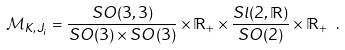<formula> <loc_0><loc_0><loc_500><loc_500>\mathcal { M } _ { K , J _ { i } } = \frac { S O ( 3 , 3 ) } { S O ( 3 ) \times S O ( 3 ) } \times \mathbb { R } _ { + } \times \frac { S l ( 2 , \mathbb { R } ) } { S O ( 2 ) } \times \mathbb { R } _ { + } \ .</formula> 